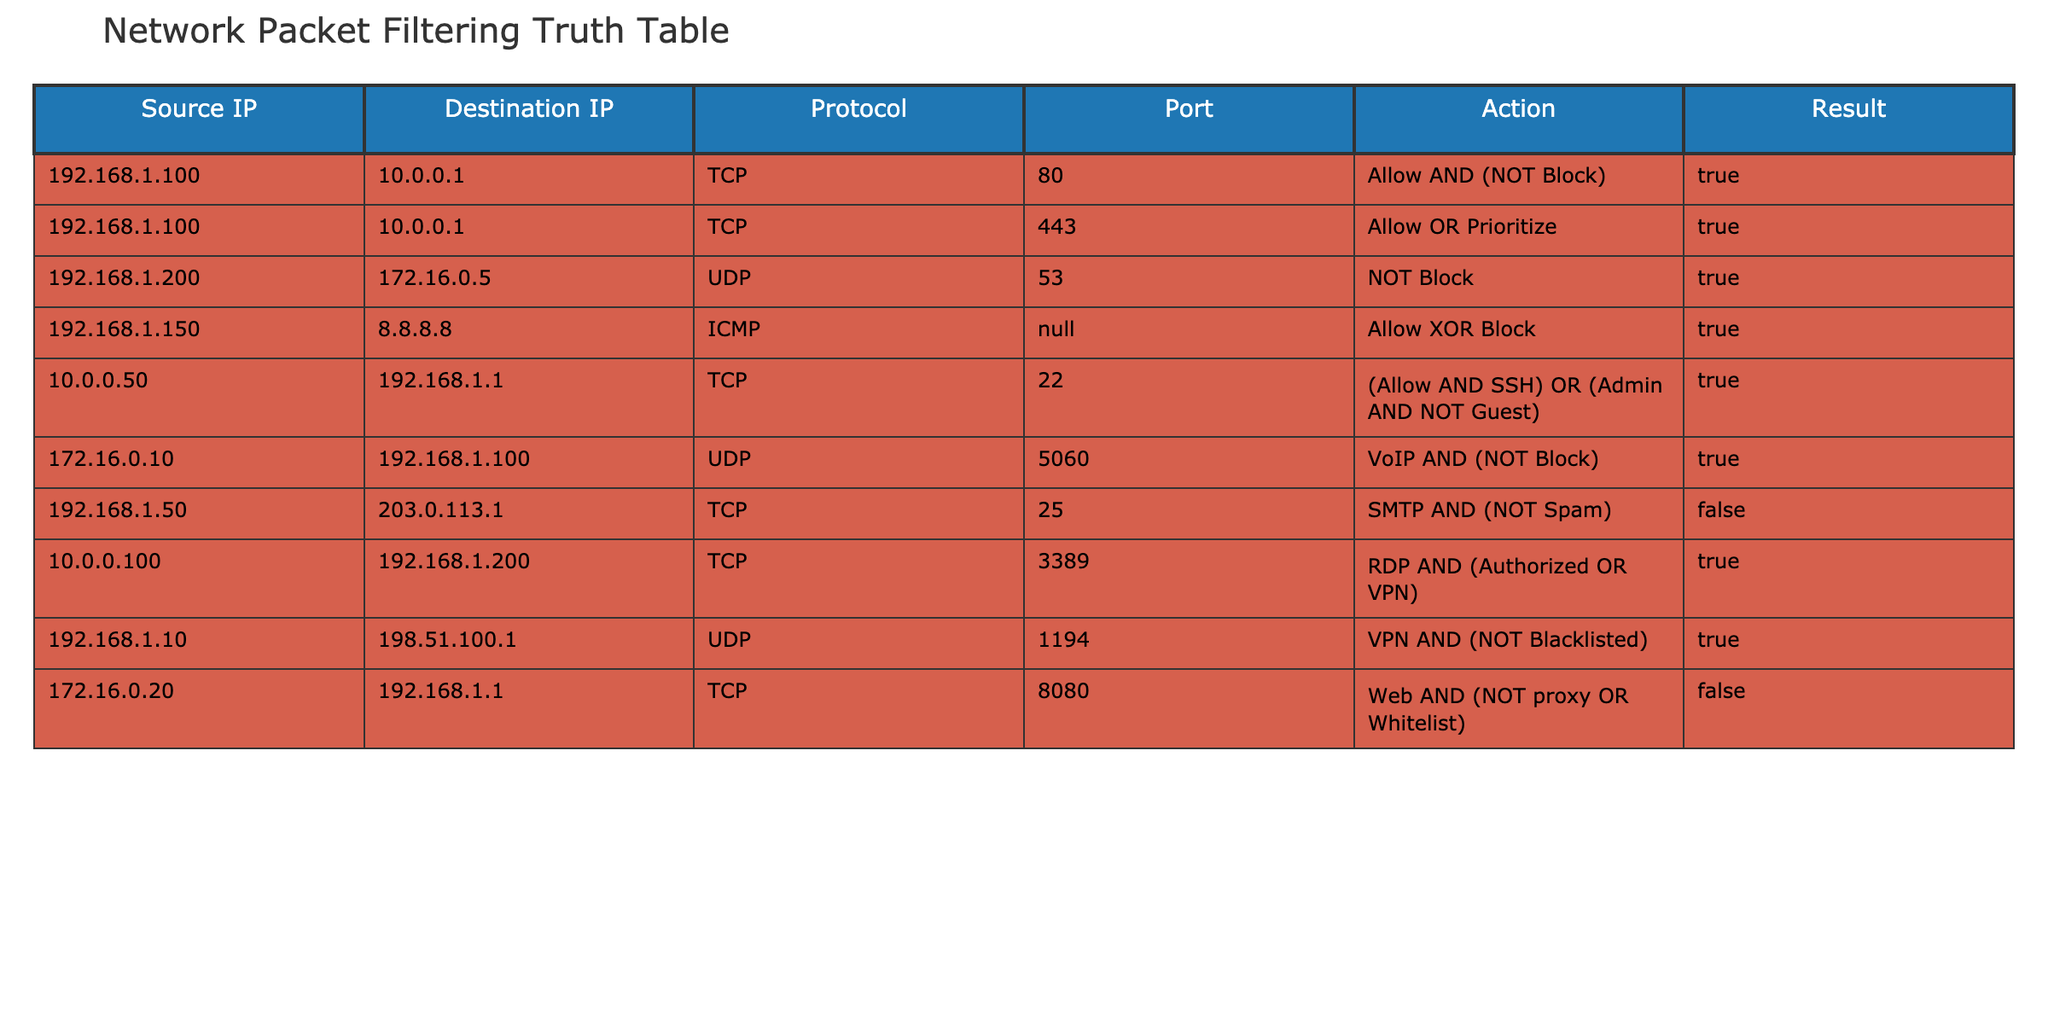What is the action for the packet coming from 192.168.1.100 to 10.0.0.1 on port 80? The table states the action for the packet from 192.168.1.100 to 10.0.0.1 on port 80 as "Allow AND (NOT Block)".
Answer: Allow AND (NOT Block) Which protocol is used for the packet from 192.168.1.150 to 8.8.8.8? Referring to the corresponding row in the table, the protocol for the packet from 192.168.1.150 to 8.8.8.8 is listed as ICMP.
Answer: ICMP How many rows indicate the action is "True"? Upon reviewing the table, there are 7 instances where "Result" is marked as "True".
Answer: 7 Is the packet from 192.168.1.50 to 203.0.113.1 on port 25 allowed? The action listed for this packet is "SMTP AND (NOT Spam)", and the result is "False". Therefore, it is not allowed.
Answer: No What is the result of packets prioritized by the action "Allow OR Prioritize"? The row with the action "Allow OR Prioritize" shows a result of "True" for the packet from 192.168.1.100 to 10.0.0.1 on port 443. Thus, the result is indeed "True".
Answer: True What is the action for the packet from 10.0.0.50 to 192.168.1.1 when it uses port 22? The action for this packet is noted as "(Allow AND SSH) OR (Admin AND NOT Guest)". Since the result is "True", the action is effectively permitted under those conditions.
Answer: (Allow AND SSH) OR (Admin AND NOT Guest) Considering only UDP packets, how many of them have a result of "True"? The rows with UDP packets are from 192.168.1.200 to 172.16.0.5 and from 172.16.0.10 to 192.168.1.100. Both have a result of "True", which makes a total of 2.
Answer: 2 What is the action for the VoIP packet and does it allow or block the connection? The action for the VoIP packet from 172.16.0.10 to 192.168.1.100 is "VoIP AND (NOT Block)", resulting in "True". This means it allows the connection.
Answer: Allows the connection Are any packets from 192.168.1.10 to 198.51.100.1 on port 1194 blocked? Since the action is "VPN AND (NOT Blacklisted)" and the result is "True", this packet is not blocked.
Answer: No 